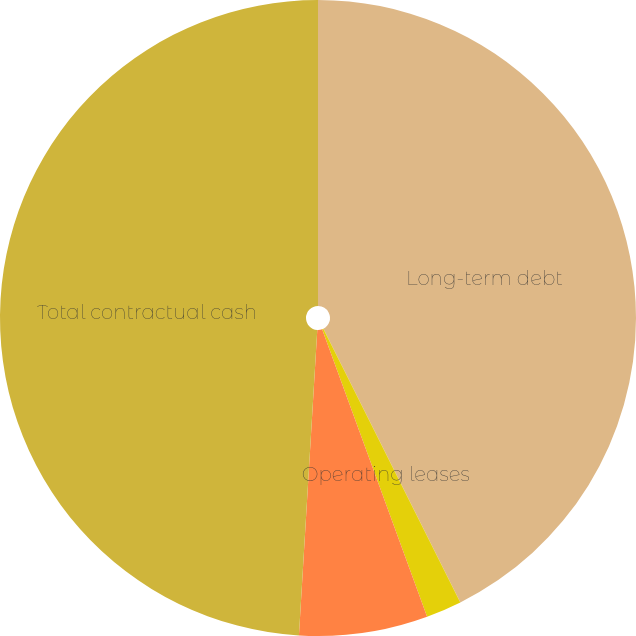Convert chart to OTSL. <chart><loc_0><loc_0><loc_500><loc_500><pie_chart><fcel>Long-term debt<fcel>Operating leases<fcel>Interest payments<fcel>Total contractual cash<nl><fcel>42.62%<fcel>1.81%<fcel>6.53%<fcel>49.05%<nl></chart> 